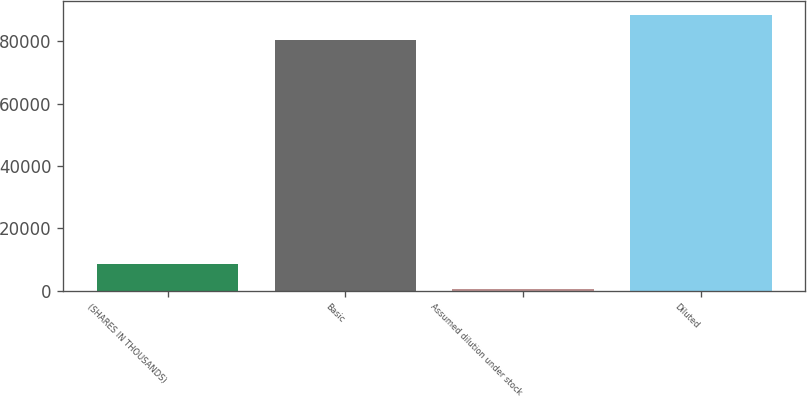Convert chart to OTSL. <chart><loc_0><loc_0><loc_500><loc_500><bar_chart><fcel>(SHARES IN THOUSANDS)<fcel>Basic<fcel>Assumed dilution under stock<fcel>Diluted<nl><fcel>8486.9<fcel>80449<fcel>442<fcel>88493.9<nl></chart> 